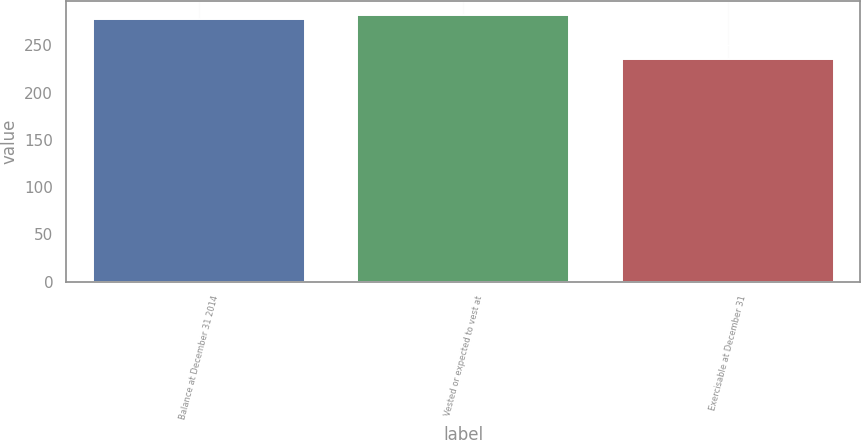<chart> <loc_0><loc_0><loc_500><loc_500><bar_chart><fcel>Balance at December 31 2014<fcel>Vested or expected to vest at<fcel>Exercisable at December 31<nl><fcel>278<fcel>282.3<fcel>235<nl></chart> 